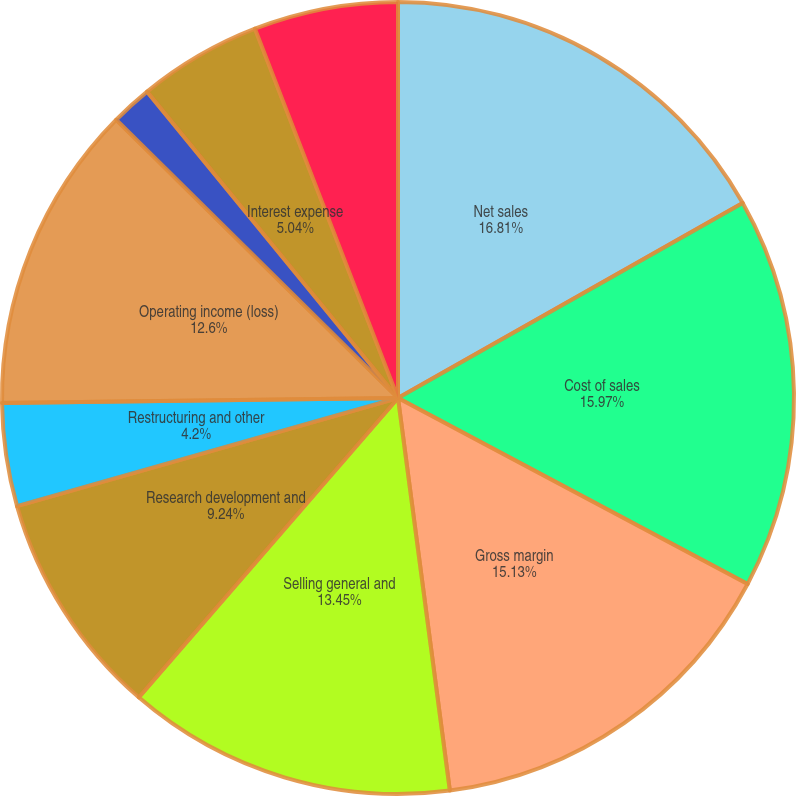Convert chart. <chart><loc_0><loc_0><loc_500><loc_500><pie_chart><fcel>Net sales<fcel>Cost of sales<fcel>Gross margin<fcel>Selling general and<fcel>Research development and<fcel>Restructuring and other<fcel>Operating income (loss)<fcel>Interest income<fcel>Interest expense<fcel>Other income (expense) net<nl><fcel>16.81%<fcel>15.97%<fcel>15.13%<fcel>13.45%<fcel>9.24%<fcel>4.2%<fcel>12.6%<fcel>1.68%<fcel>5.04%<fcel>5.88%<nl></chart> 